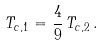Convert formula to latex. <formula><loc_0><loc_0><loc_500><loc_500>T _ { c , 1 } = \frac { 4 } { 9 } \, T _ { c , 2 } \, .</formula> 